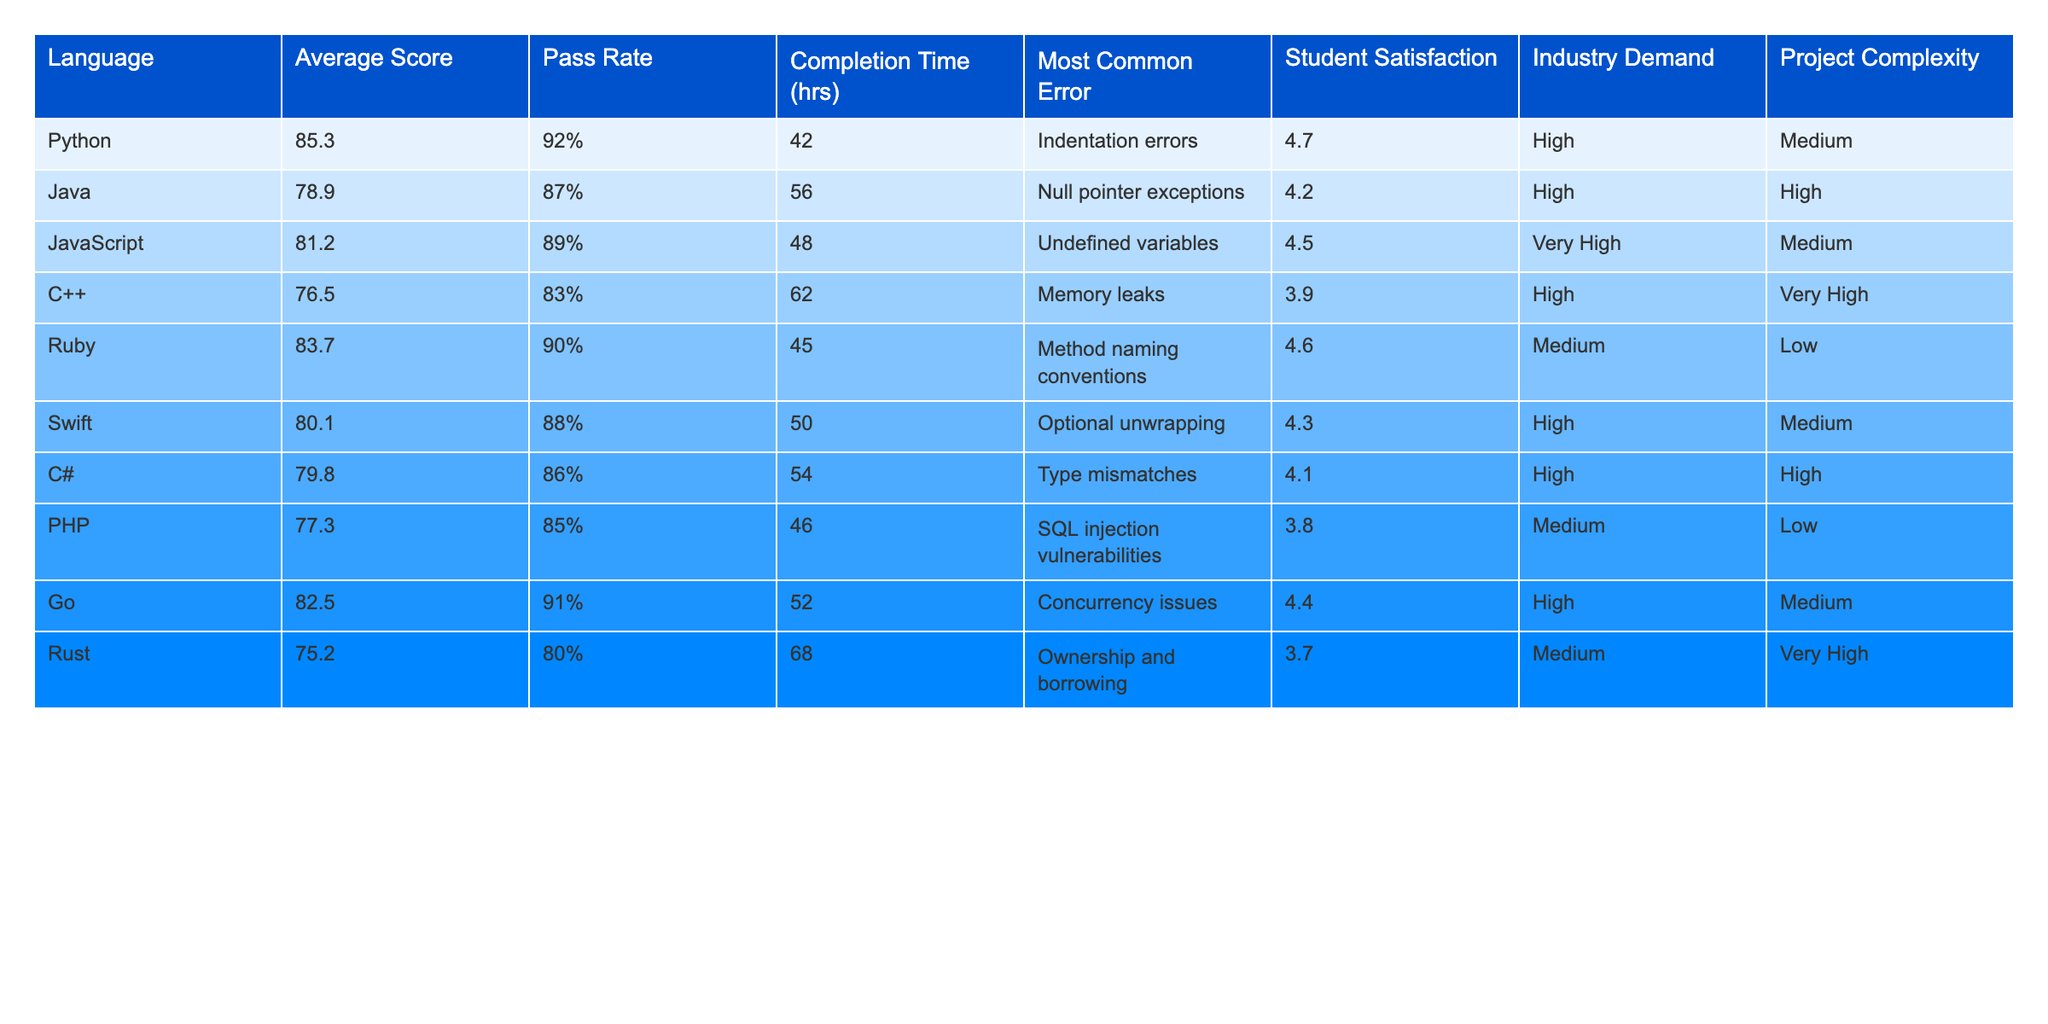What is the average score for Python? The table shows that the average score for Python is 85.3.
Answer: 85.3 Which language has the highest pass rate? According to the table, JavaScript has the highest pass rate at 89%.
Answer: JavaScript What is the most common error in C++? The table indicates that the most common error in C++ is memory leaks.
Answer: Memory leaks What is the student satisfaction level for Ruby? The table shows that the student satisfaction level for Ruby is 4.6.
Answer: 4.6 Which programming language has the lowest average score? Looking at the average scores, Rust has the lowest average score of 75.2.
Answer: Rust Is the industry demand for Go high? The table states that the industry demand for Go is high.
Answer: Yes What is the difference in completion time between Python and Java? Python's completion time is 42 hours, while Java's is 56 hours. The difference is 56 - 42 = 14 hours.
Answer: 14 hours What is the average score of languages with a high industry demand? The languages with high industry demand are Python, Java, JavaScript, C#, and Go. Their scores are (85.3 + 78.9 + 81.2 + 79.8 + 82.5) = 407. The average is 407/5 = 81.4.
Answer: 81.4 For which language is the most common error related to undefined variables? The table shows that the most common error related to undefined variables occurs in JavaScript.
Answer: JavaScript Is the completion time for Ruby lower than that of C#? Ruby's completion time is 45 hours, while C#'s is 54 hours. Since 45 < 54, this statement is true.
Answer: Yes What complex comparison can be made between Python and Rust regarding satisfaction and average score? Python has an average score of 85.3 and a satisfaction level of 4.7, while Rust has an average score of 75.2 and a satisfaction level of 3.7. This shows that Python has both a higher average score and higher satisfaction compared to Rust.
Answer: Python is better in both metrics 